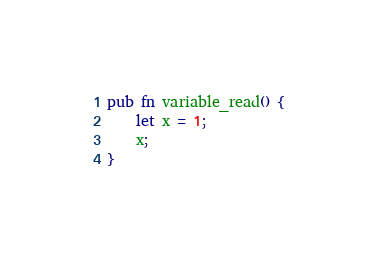Convert code to text. <code><loc_0><loc_0><loc_500><loc_500><_Rust_>pub fn variable_read() {
    let x = 1;
    x;
}
</code> 